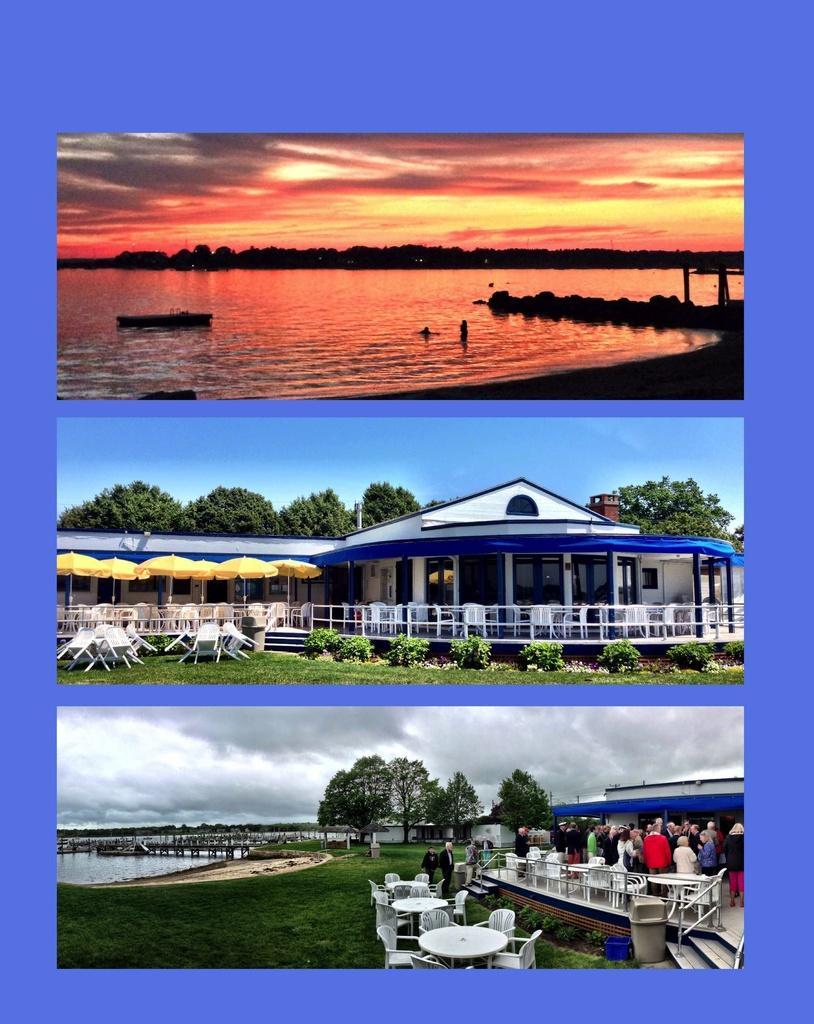Describe this image in one or two sentences. In this picture I can see collage of three images, in the first image I can see a boat in the water and I can see sky, in the second picture I can see building, few trees, plants and few umbrellas and I can see chairs and a blue sky, In the third image I can see building and few people are standing and I can see tables, chairs and few trees and I can see water and grass on the ground and I can see cloudy sky. 